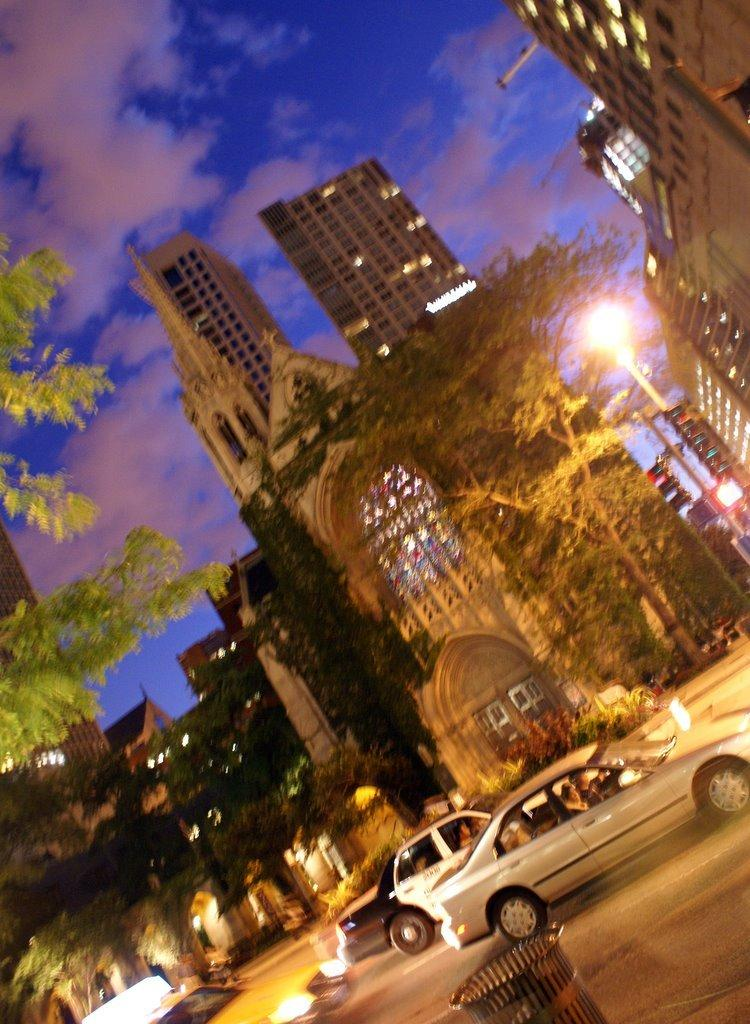What is the main feature of the image? There is a road in the image. What is happening on the road? Vehicles are moving on the road. What can be seen in the background of the image? There are light poles, trees, buildings, and the sky visible in the background of the image. What type of juice is being served at the restaurant in the image? There is no restaurant or juice present in the image; it features a road with moving vehicles and a background with light poles, trees, buildings, and the sky. 